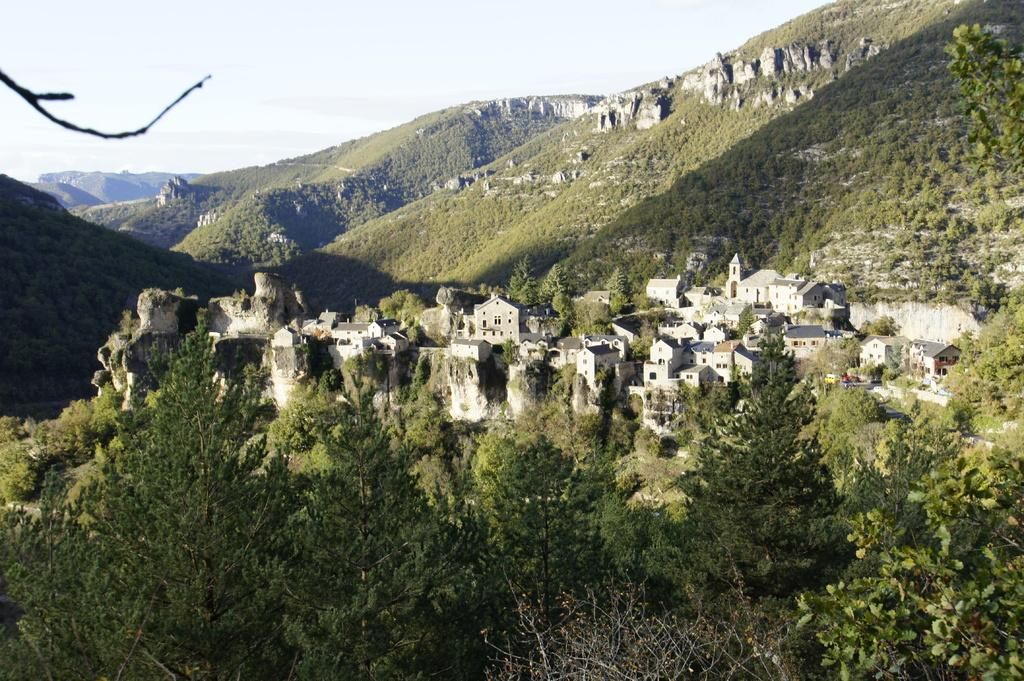What can be seen in the sky in the image? The sky is visible in the image. What type of natural landscape is present in the image? There are hills in the image. What type of man-made structures can be seen in the image? There are buildings in the image. What type of vegetation is present in the image? Trees are present in the image. What type of corn can be seen growing on the hills in the image? There is no corn visible in the image; the hills are covered with vegetation, but it is not specified as corn. 